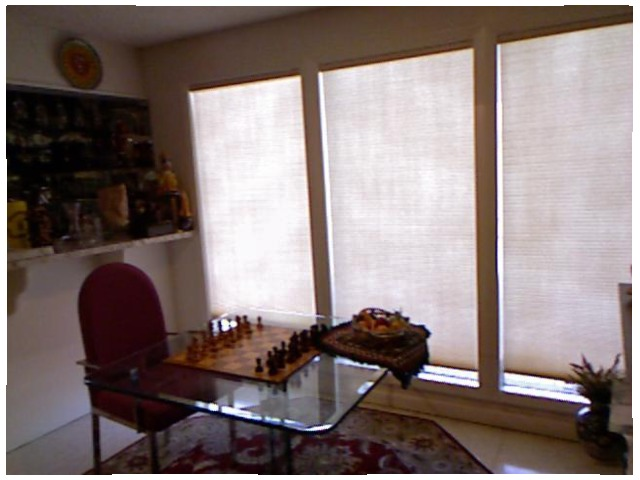<image>
Can you confirm if the chair is under the table? Yes. The chair is positioned underneath the table, with the table above it in the vertical space. Is there a chess board under the glass table? No. The chess board is not positioned under the glass table. The vertical relationship between these objects is different. Is there a chess board on the table? Yes. Looking at the image, I can see the chess board is positioned on top of the table, with the table providing support. Where is the chess in relation to the floor? Is it on the floor? No. The chess is not positioned on the floor. They may be near each other, but the chess is not supported by or resting on top of the floor. Is the chair on the table? No. The chair is not positioned on the table. They may be near each other, but the chair is not supported by or resting on top of the table. 